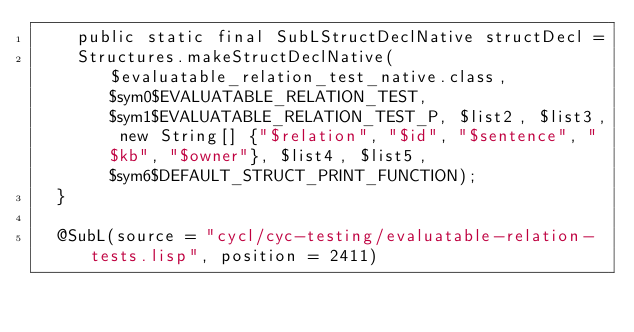Convert code to text. <code><loc_0><loc_0><loc_500><loc_500><_Java_>    public static final SubLStructDeclNative structDecl =
    Structures.makeStructDeclNative($evaluatable_relation_test_native.class, $sym0$EVALUATABLE_RELATION_TEST, $sym1$EVALUATABLE_RELATION_TEST_P, $list2, $list3, new String[] {"$relation", "$id", "$sentence", "$kb", "$owner"}, $list4, $list5, $sym6$DEFAULT_STRUCT_PRINT_FUNCTION);
  }

  @SubL(source = "cycl/cyc-testing/evaluatable-relation-tests.lisp", position = 2411) </code> 